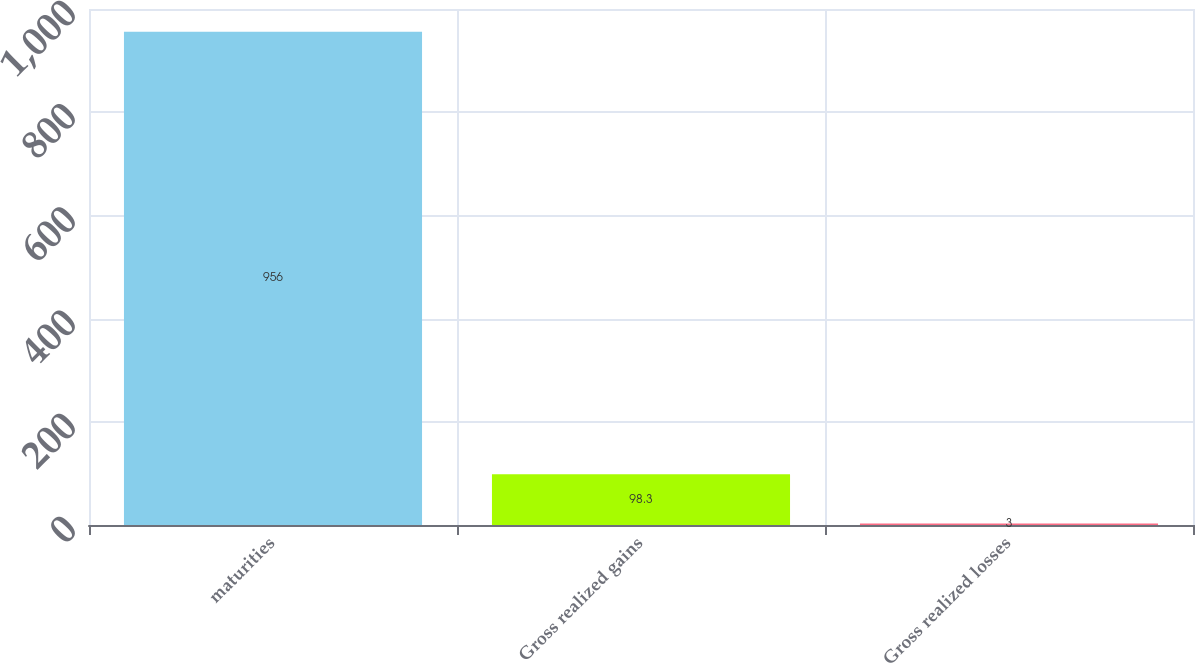Convert chart. <chart><loc_0><loc_0><loc_500><loc_500><bar_chart><fcel>maturities<fcel>Gross realized gains<fcel>Gross realized losses<nl><fcel>956<fcel>98.3<fcel>3<nl></chart> 